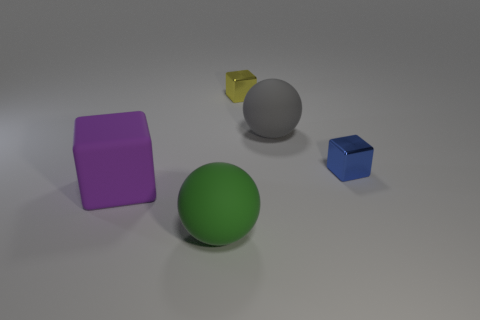What number of other cubes are the same color as the big matte cube?
Provide a succinct answer. 0. What is the color of the other shiny object that is the same shape as the small yellow shiny object?
Provide a succinct answer. Blue. The cube that is in front of the gray thing and right of the big purple rubber object is made of what material?
Provide a succinct answer. Metal. Do the large ball behind the big purple thing and the blue thing behind the big purple rubber block have the same material?
Provide a short and direct response. No. What size is the purple matte object?
Provide a succinct answer. Large. There is another object that is the same shape as the big green thing; what size is it?
Keep it short and to the point. Large. What number of matte things are right of the yellow thing?
Your answer should be compact. 1. The small metal object that is in front of the small metal thing that is left of the blue metallic cube is what color?
Your answer should be very brief. Blue. Is there any other thing that is the same shape as the purple thing?
Your answer should be very brief. Yes. Are there the same number of tiny blue cubes behind the yellow cube and metal objects behind the purple rubber object?
Your response must be concise. No. 